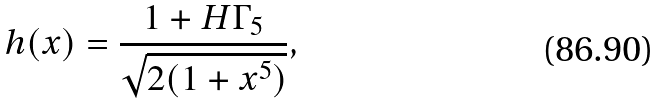<formula> <loc_0><loc_0><loc_500><loc_500>h ( x ) = \frac { 1 + H \Gamma _ { 5 } } { \sqrt { 2 ( 1 + x ^ { 5 } ) } } ,</formula> 